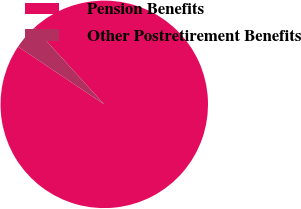Convert chart to OTSL. <chart><loc_0><loc_0><loc_500><loc_500><pie_chart><fcel>Pension Benefits<fcel>Other Postretirement Benefits<nl><fcel>96.15%<fcel>3.85%<nl></chart> 